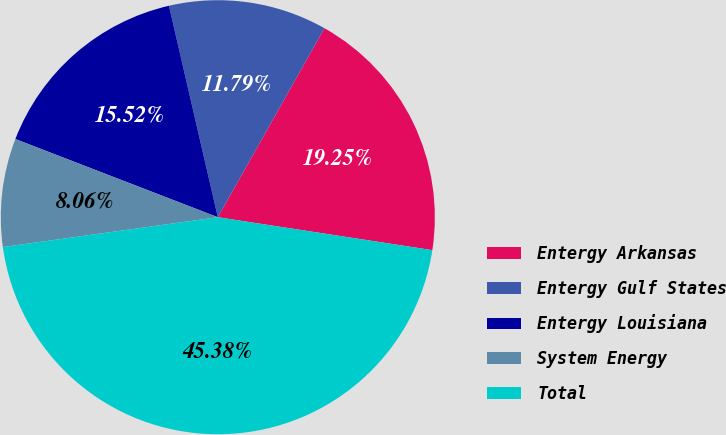Convert chart to OTSL. <chart><loc_0><loc_0><loc_500><loc_500><pie_chart><fcel>Entergy Arkansas<fcel>Entergy Gulf States<fcel>Entergy Louisiana<fcel>System Energy<fcel>Total<nl><fcel>19.25%<fcel>11.79%<fcel>15.52%<fcel>8.06%<fcel>45.38%<nl></chart> 